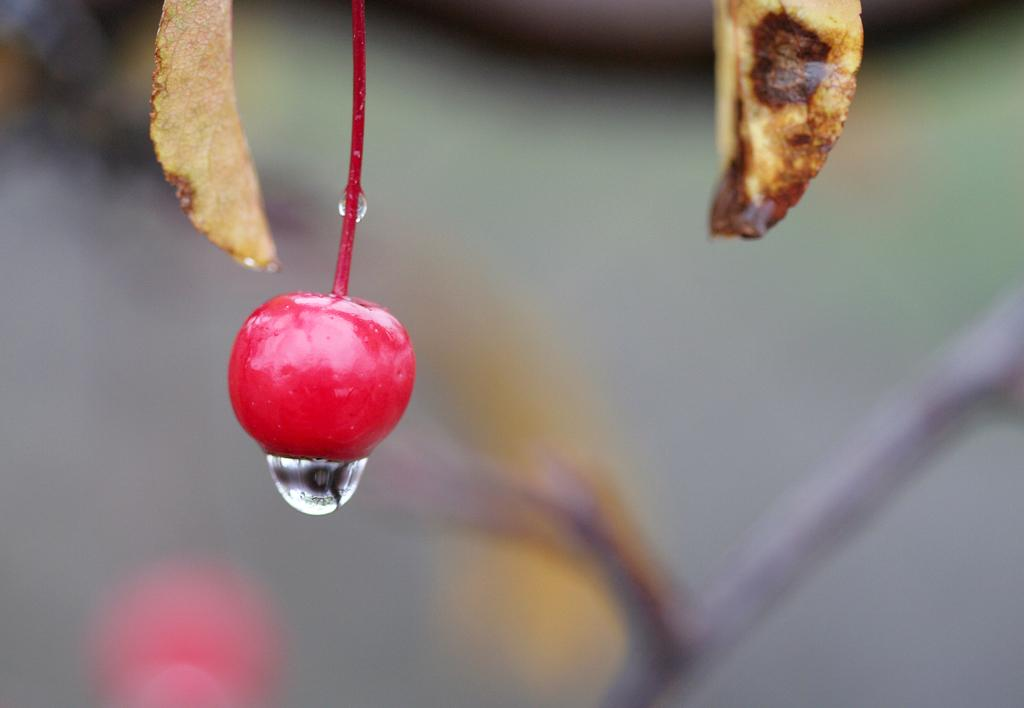What is the main subject of the image? The main subject of the image is a cherry. Can you describe any specific details about the cherry? Yes, there is a water droplet under the cherry in the image. How is the background of the image depicted? The background of the cherry is blurred. What advice does the grandfather give to the cherry in the image? There is no grandfather present in the image, and therefore no advice can be given. How many letters are visible in the image? There are no letters visible in the image; it features a cherry with a water droplet and a blurred background. 